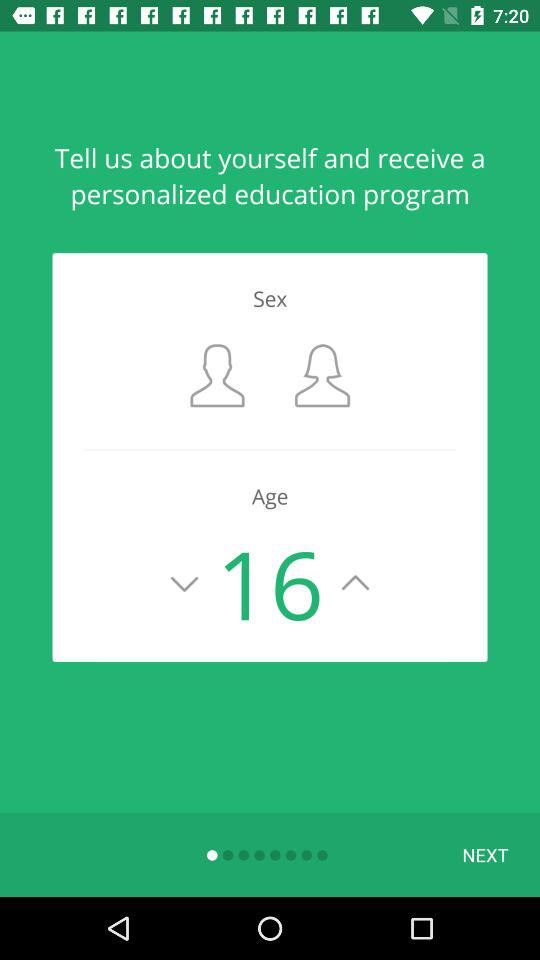What is the age of the user?
Answer the question using a single word or phrase. 16 